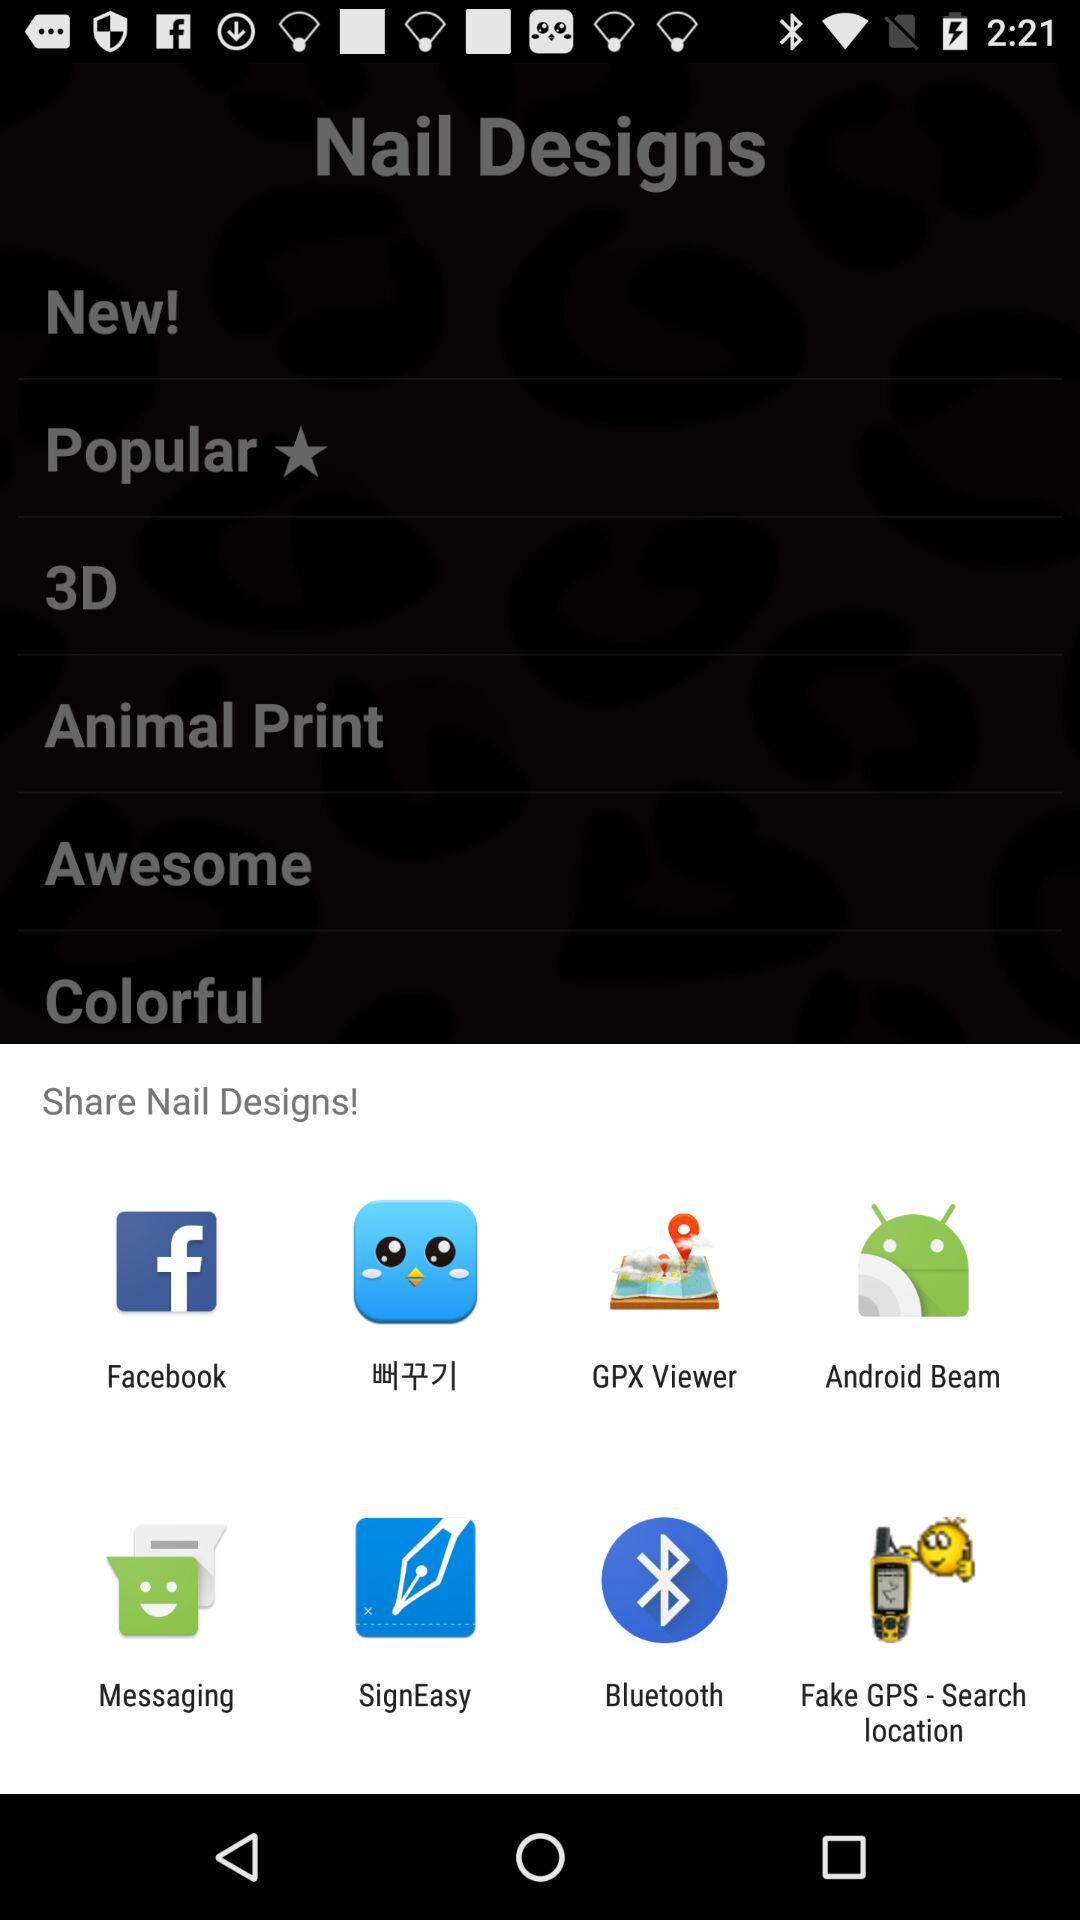Which options are given for sharing nail designs?
When the provided information is insufficient, respond with <no answer>. <no answer> 